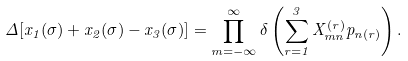<formula> <loc_0><loc_0><loc_500><loc_500>\Delta [ x _ { 1 } ( \sigma ) + x _ { 2 } ( \sigma ) - x _ { 3 } ( \sigma ) ] = \prod _ { m = - \infty } ^ { \infty } \delta \left ( \sum _ { r = 1 } ^ { 3 } X ^ { ( r ) } _ { m n } p _ { n ( r ) } \right ) .</formula> 